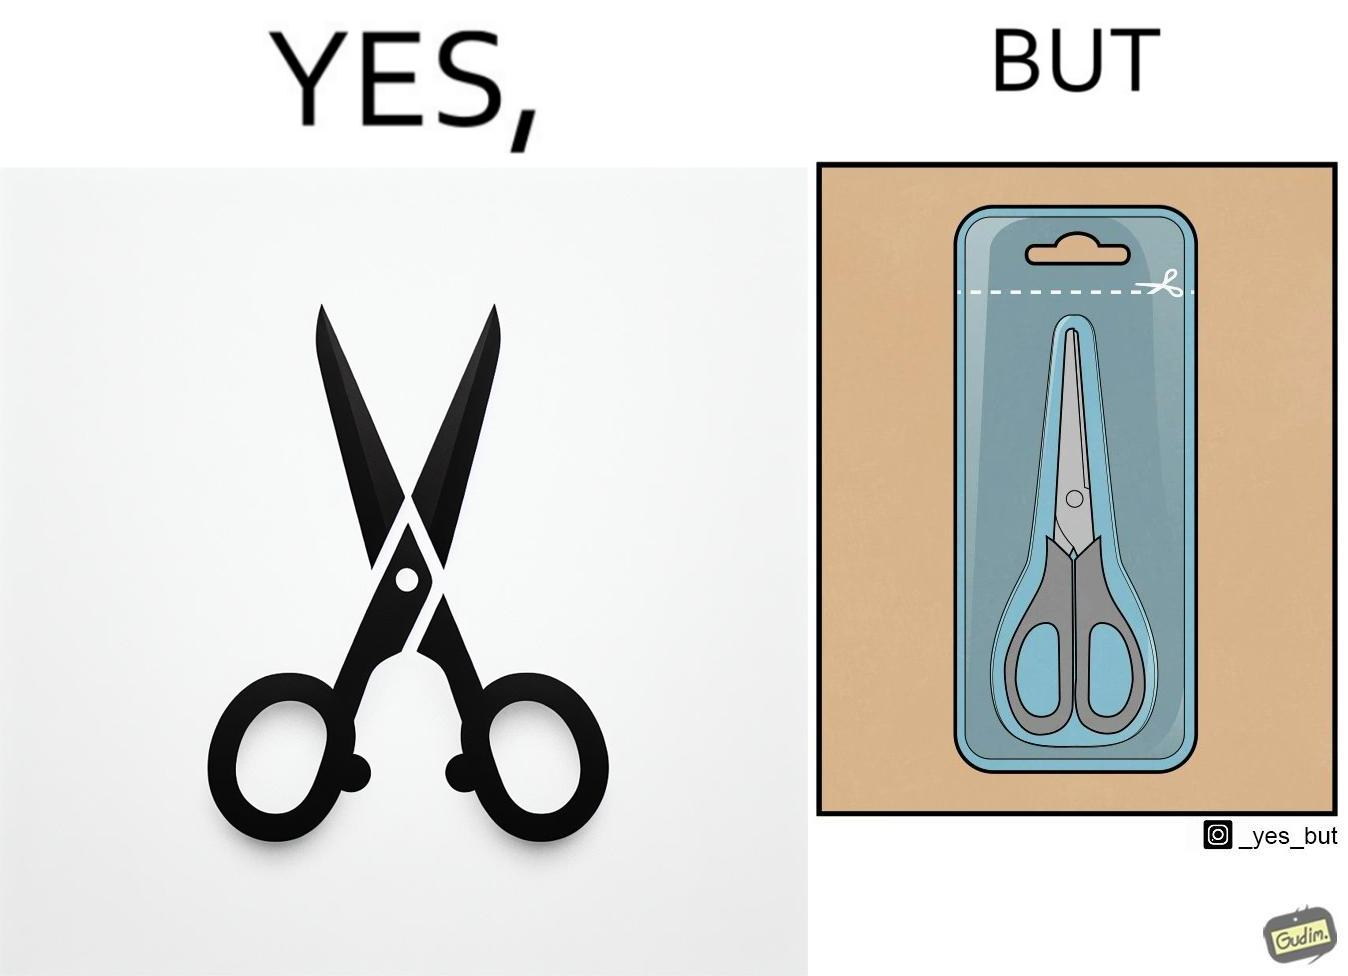Describe what you see in the left and right parts of this image. In the left part of the image: a pair of scissors In the right part of the image: a pair of scissors inside a packaging, with a marking at the top showing that you would need to open it using a pair of scissors. 